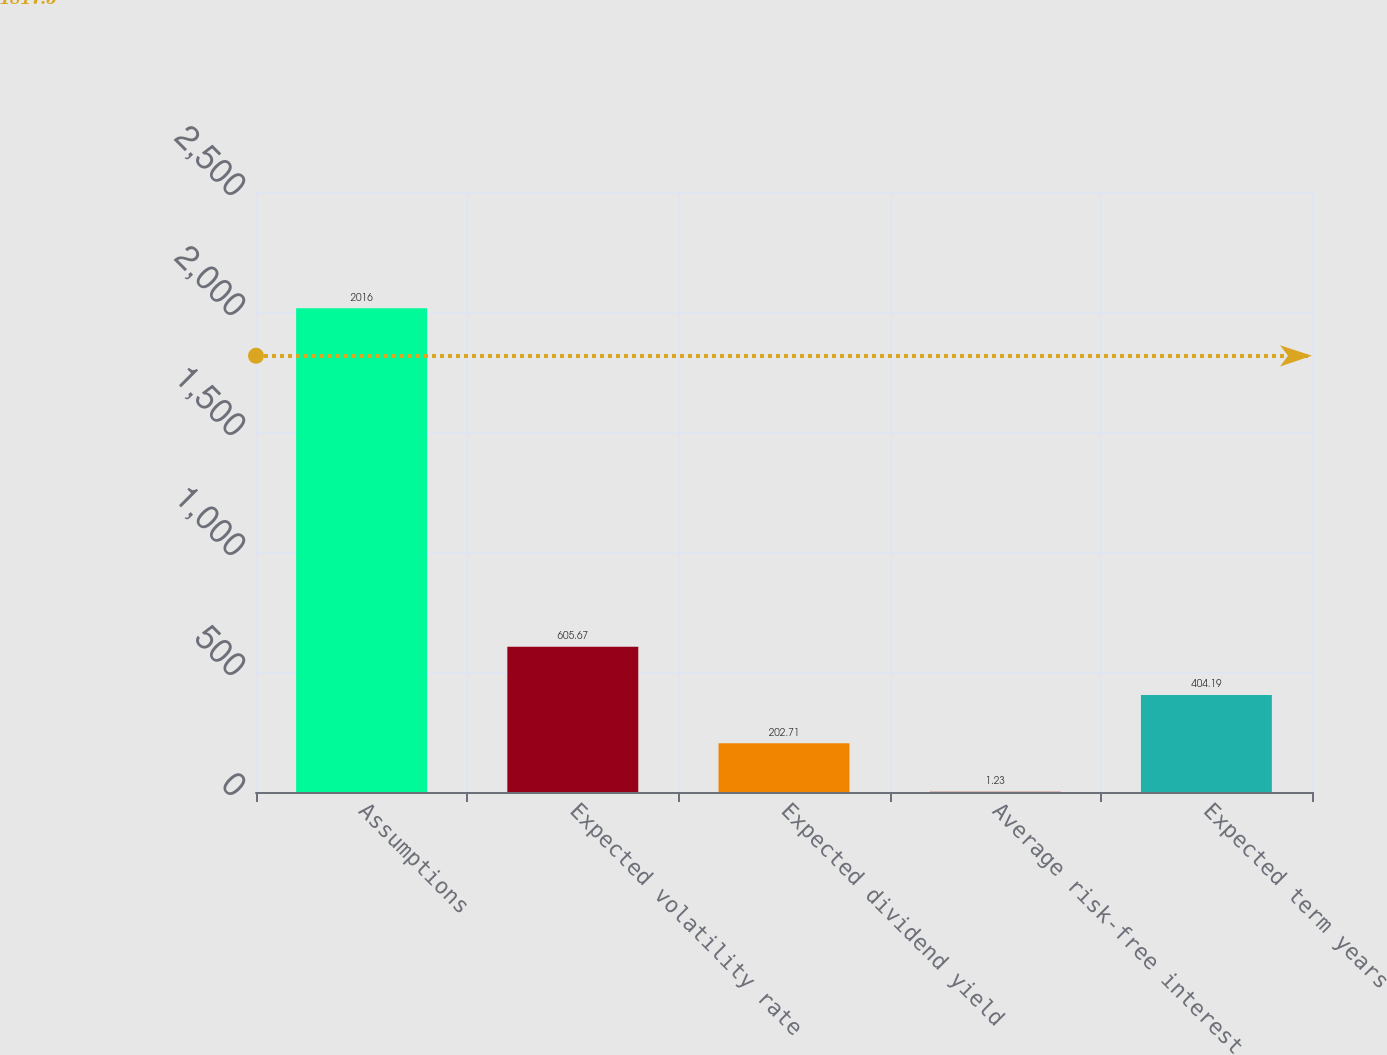<chart> <loc_0><loc_0><loc_500><loc_500><bar_chart><fcel>Assumptions<fcel>Expected volatility rate<fcel>Expected dividend yield<fcel>Average risk-free interest<fcel>Expected term years<nl><fcel>2016<fcel>605.67<fcel>202.71<fcel>1.23<fcel>404.19<nl></chart> 